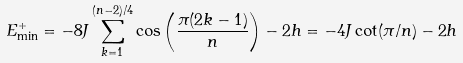<formula> <loc_0><loc_0><loc_500><loc_500>E _ { \min } ^ { + } = - 8 J \sum _ { k = 1 } ^ { ( n - 2 ) / 4 } \cos \left ( \frac { \pi ( 2 k - 1 ) } { n } \right ) - 2 h = - 4 J \cot ( \pi / n ) - 2 h \,</formula> 